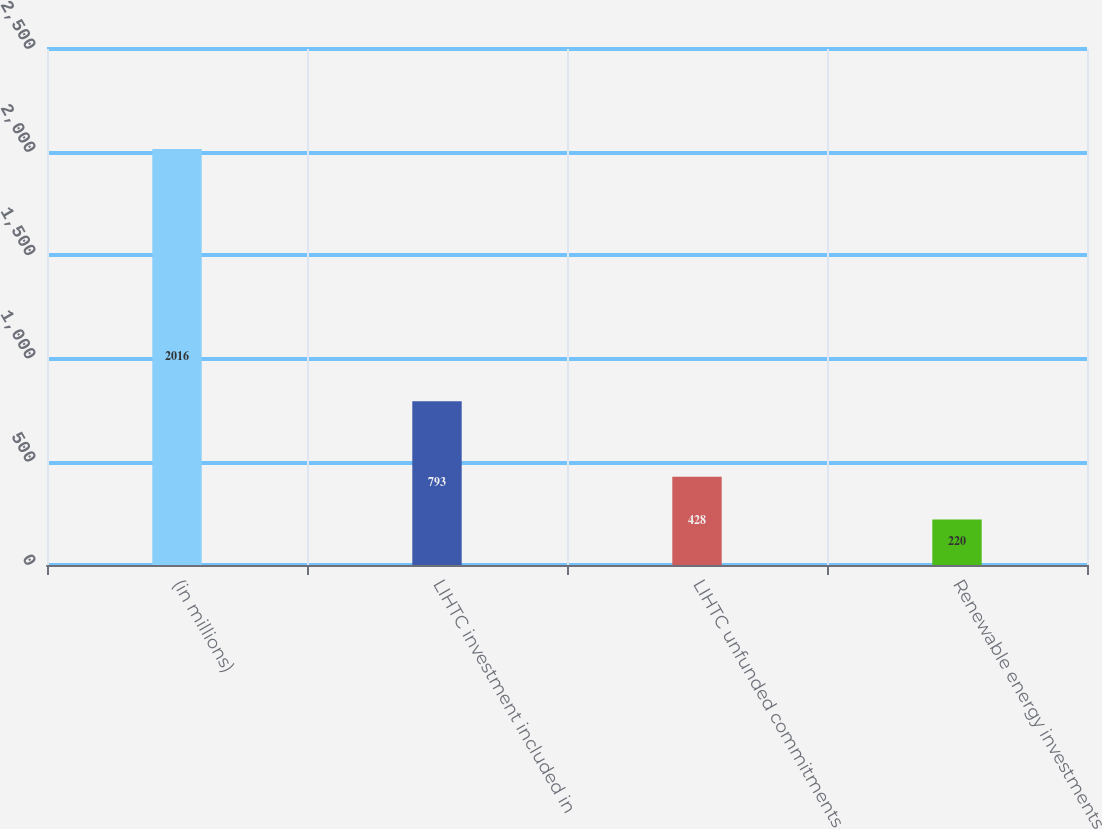<chart> <loc_0><loc_0><loc_500><loc_500><bar_chart><fcel>(in millions)<fcel>LIHTC investment included in<fcel>LIHTC unfunded commitments<fcel>Renewable energy investments<nl><fcel>2016<fcel>793<fcel>428<fcel>220<nl></chart> 